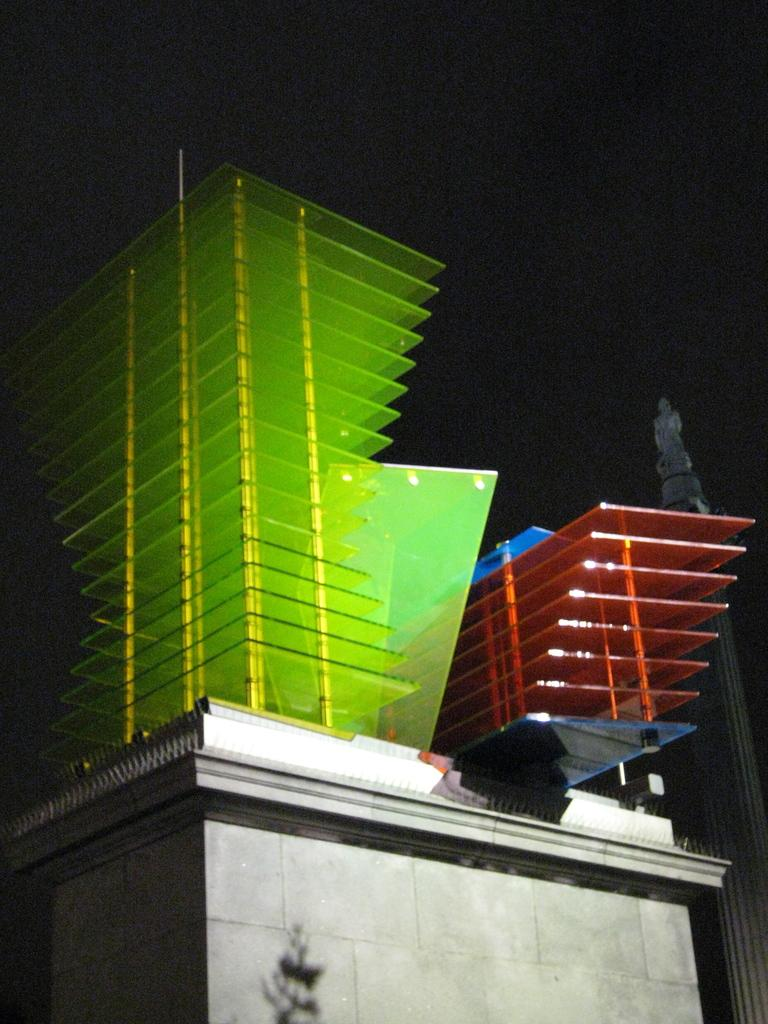What objects are present in the image? There are glasses in the image. Can you describe the colors of the glasses? The glasses are green, blue, and red in color. What is visible behind the glasses in the image? There is a wall in the image. How would you describe the overall lighting in the image? The background of the image is dark. Is the cook wearing a cap in the image? There is no cook or cap present in the image; it only features glasses of different colors. 